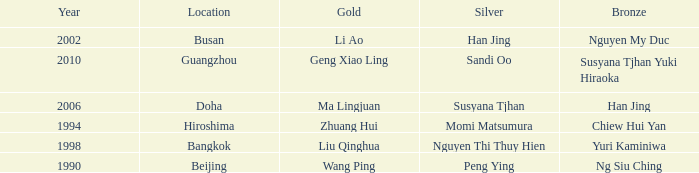What Silver has the Location of Guangzhou? Sandi Oo. 